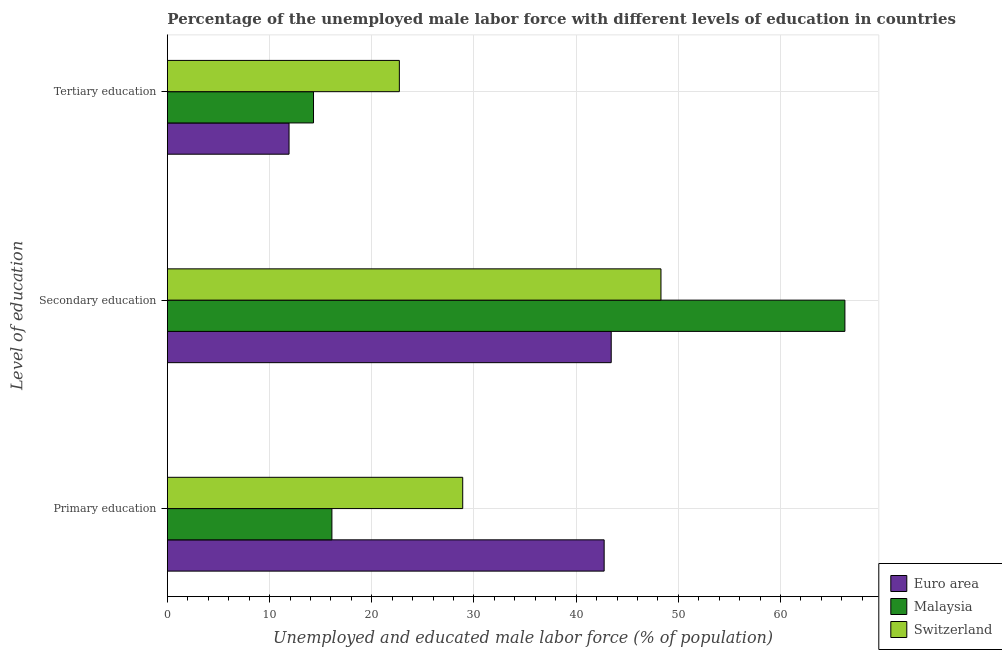Are the number of bars per tick equal to the number of legend labels?
Provide a succinct answer. Yes. Are the number of bars on each tick of the Y-axis equal?
Your response must be concise. Yes. How many bars are there on the 3rd tick from the top?
Ensure brevity in your answer.  3. What is the label of the 1st group of bars from the top?
Make the answer very short. Tertiary education. What is the percentage of male labor force who received secondary education in Euro area?
Your answer should be very brief. 43.43. Across all countries, what is the maximum percentage of male labor force who received primary education?
Offer a terse response. 42.74. Across all countries, what is the minimum percentage of male labor force who received tertiary education?
Make the answer very short. 11.9. In which country was the percentage of male labor force who received tertiary education maximum?
Ensure brevity in your answer.  Switzerland. What is the total percentage of male labor force who received secondary education in the graph?
Offer a very short reply. 158.03. What is the difference between the percentage of male labor force who received secondary education in Switzerland and that in Malaysia?
Provide a succinct answer. -18. What is the difference between the percentage of male labor force who received secondary education in Malaysia and the percentage of male labor force who received tertiary education in Euro area?
Give a very brief answer. 54.4. What is the average percentage of male labor force who received primary education per country?
Offer a terse response. 29.25. What is the difference between the percentage of male labor force who received secondary education and percentage of male labor force who received tertiary education in Switzerland?
Your response must be concise. 25.6. What is the ratio of the percentage of male labor force who received primary education in Malaysia to that in Switzerland?
Make the answer very short. 0.56. Is the percentage of male labor force who received tertiary education in Switzerland less than that in Malaysia?
Provide a short and direct response. No. Is the difference between the percentage of male labor force who received tertiary education in Malaysia and Switzerland greater than the difference between the percentage of male labor force who received primary education in Malaysia and Switzerland?
Offer a very short reply. Yes. What is the difference between the highest and the second highest percentage of male labor force who received tertiary education?
Give a very brief answer. 8.4. What is the difference between the highest and the lowest percentage of male labor force who received primary education?
Ensure brevity in your answer.  26.64. In how many countries, is the percentage of male labor force who received tertiary education greater than the average percentage of male labor force who received tertiary education taken over all countries?
Offer a terse response. 1. What does the 1st bar from the bottom in Tertiary education represents?
Your response must be concise. Euro area. How many countries are there in the graph?
Keep it short and to the point. 3. Does the graph contain any zero values?
Make the answer very short. No. Where does the legend appear in the graph?
Keep it short and to the point. Bottom right. What is the title of the graph?
Your answer should be compact. Percentage of the unemployed male labor force with different levels of education in countries. What is the label or title of the X-axis?
Ensure brevity in your answer.  Unemployed and educated male labor force (% of population). What is the label or title of the Y-axis?
Keep it short and to the point. Level of education. What is the Unemployed and educated male labor force (% of population) of Euro area in Primary education?
Your answer should be very brief. 42.74. What is the Unemployed and educated male labor force (% of population) in Malaysia in Primary education?
Your answer should be compact. 16.1. What is the Unemployed and educated male labor force (% of population) of Switzerland in Primary education?
Keep it short and to the point. 28.9. What is the Unemployed and educated male labor force (% of population) of Euro area in Secondary education?
Your answer should be compact. 43.43. What is the Unemployed and educated male labor force (% of population) in Malaysia in Secondary education?
Keep it short and to the point. 66.3. What is the Unemployed and educated male labor force (% of population) of Switzerland in Secondary education?
Offer a terse response. 48.3. What is the Unemployed and educated male labor force (% of population) in Euro area in Tertiary education?
Your response must be concise. 11.9. What is the Unemployed and educated male labor force (% of population) of Malaysia in Tertiary education?
Give a very brief answer. 14.3. What is the Unemployed and educated male labor force (% of population) in Switzerland in Tertiary education?
Make the answer very short. 22.7. Across all Level of education, what is the maximum Unemployed and educated male labor force (% of population) in Euro area?
Ensure brevity in your answer.  43.43. Across all Level of education, what is the maximum Unemployed and educated male labor force (% of population) of Malaysia?
Offer a terse response. 66.3. Across all Level of education, what is the maximum Unemployed and educated male labor force (% of population) in Switzerland?
Your answer should be compact. 48.3. Across all Level of education, what is the minimum Unemployed and educated male labor force (% of population) of Euro area?
Make the answer very short. 11.9. Across all Level of education, what is the minimum Unemployed and educated male labor force (% of population) of Malaysia?
Your response must be concise. 14.3. Across all Level of education, what is the minimum Unemployed and educated male labor force (% of population) of Switzerland?
Offer a very short reply. 22.7. What is the total Unemployed and educated male labor force (% of population) in Euro area in the graph?
Your answer should be very brief. 98.08. What is the total Unemployed and educated male labor force (% of population) of Malaysia in the graph?
Offer a terse response. 96.7. What is the total Unemployed and educated male labor force (% of population) of Switzerland in the graph?
Keep it short and to the point. 99.9. What is the difference between the Unemployed and educated male labor force (% of population) in Euro area in Primary education and that in Secondary education?
Give a very brief answer. -0.69. What is the difference between the Unemployed and educated male labor force (% of population) in Malaysia in Primary education and that in Secondary education?
Make the answer very short. -50.2. What is the difference between the Unemployed and educated male labor force (% of population) in Switzerland in Primary education and that in Secondary education?
Your answer should be very brief. -19.4. What is the difference between the Unemployed and educated male labor force (% of population) of Euro area in Primary education and that in Tertiary education?
Your answer should be compact. 30.84. What is the difference between the Unemployed and educated male labor force (% of population) in Malaysia in Primary education and that in Tertiary education?
Ensure brevity in your answer.  1.8. What is the difference between the Unemployed and educated male labor force (% of population) of Euro area in Secondary education and that in Tertiary education?
Ensure brevity in your answer.  31.53. What is the difference between the Unemployed and educated male labor force (% of population) of Malaysia in Secondary education and that in Tertiary education?
Your answer should be compact. 52. What is the difference between the Unemployed and educated male labor force (% of population) in Switzerland in Secondary education and that in Tertiary education?
Ensure brevity in your answer.  25.6. What is the difference between the Unemployed and educated male labor force (% of population) in Euro area in Primary education and the Unemployed and educated male labor force (% of population) in Malaysia in Secondary education?
Offer a very short reply. -23.56. What is the difference between the Unemployed and educated male labor force (% of population) of Euro area in Primary education and the Unemployed and educated male labor force (% of population) of Switzerland in Secondary education?
Provide a short and direct response. -5.56. What is the difference between the Unemployed and educated male labor force (% of population) in Malaysia in Primary education and the Unemployed and educated male labor force (% of population) in Switzerland in Secondary education?
Make the answer very short. -32.2. What is the difference between the Unemployed and educated male labor force (% of population) of Euro area in Primary education and the Unemployed and educated male labor force (% of population) of Malaysia in Tertiary education?
Make the answer very short. 28.44. What is the difference between the Unemployed and educated male labor force (% of population) of Euro area in Primary education and the Unemployed and educated male labor force (% of population) of Switzerland in Tertiary education?
Provide a short and direct response. 20.04. What is the difference between the Unemployed and educated male labor force (% of population) of Euro area in Secondary education and the Unemployed and educated male labor force (% of population) of Malaysia in Tertiary education?
Make the answer very short. 29.13. What is the difference between the Unemployed and educated male labor force (% of population) of Euro area in Secondary education and the Unemployed and educated male labor force (% of population) of Switzerland in Tertiary education?
Ensure brevity in your answer.  20.73. What is the difference between the Unemployed and educated male labor force (% of population) in Malaysia in Secondary education and the Unemployed and educated male labor force (% of population) in Switzerland in Tertiary education?
Ensure brevity in your answer.  43.6. What is the average Unemployed and educated male labor force (% of population) in Euro area per Level of education?
Keep it short and to the point. 32.69. What is the average Unemployed and educated male labor force (% of population) in Malaysia per Level of education?
Give a very brief answer. 32.23. What is the average Unemployed and educated male labor force (% of population) in Switzerland per Level of education?
Offer a terse response. 33.3. What is the difference between the Unemployed and educated male labor force (% of population) in Euro area and Unemployed and educated male labor force (% of population) in Malaysia in Primary education?
Make the answer very short. 26.64. What is the difference between the Unemployed and educated male labor force (% of population) of Euro area and Unemployed and educated male labor force (% of population) of Switzerland in Primary education?
Your answer should be compact. 13.84. What is the difference between the Unemployed and educated male labor force (% of population) in Malaysia and Unemployed and educated male labor force (% of population) in Switzerland in Primary education?
Your answer should be compact. -12.8. What is the difference between the Unemployed and educated male labor force (% of population) in Euro area and Unemployed and educated male labor force (% of population) in Malaysia in Secondary education?
Make the answer very short. -22.87. What is the difference between the Unemployed and educated male labor force (% of population) in Euro area and Unemployed and educated male labor force (% of population) in Switzerland in Secondary education?
Make the answer very short. -4.87. What is the difference between the Unemployed and educated male labor force (% of population) of Euro area and Unemployed and educated male labor force (% of population) of Malaysia in Tertiary education?
Offer a very short reply. -2.4. What is the difference between the Unemployed and educated male labor force (% of population) of Euro area and Unemployed and educated male labor force (% of population) of Switzerland in Tertiary education?
Provide a short and direct response. -10.79. What is the ratio of the Unemployed and educated male labor force (% of population) of Euro area in Primary education to that in Secondary education?
Offer a very short reply. 0.98. What is the ratio of the Unemployed and educated male labor force (% of population) of Malaysia in Primary education to that in Secondary education?
Your response must be concise. 0.24. What is the ratio of the Unemployed and educated male labor force (% of population) of Switzerland in Primary education to that in Secondary education?
Your answer should be compact. 0.6. What is the ratio of the Unemployed and educated male labor force (% of population) in Euro area in Primary education to that in Tertiary education?
Your answer should be compact. 3.59. What is the ratio of the Unemployed and educated male labor force (% of population) in Malaysia in Primary education to that in Tertiary education?
Your response must be concise. 1.13. What is the ratio of the Unemployed and educated male labor force (% of population) in Switzerland in Primary education to that in Tertiary education?
Your response must be concise. 1.27. What is the ratio of the Unemployed and educated male labor force (% of population) of Euro area in Secondary education to that in Tertiary education?
Provide a succinct answer. 3.65. What is the ratio of the Unemployed and educated male labor force (% of population) in Malaysia in Secondary education to that in Tertiary education?
Your response must be concise. 4.64. What is the ratio of the Unemployed and educated male labor force (% of population) in Switzerland in Secondary education to that in Tertiary education?
Your answer should be very brief. 2.13. What is the difference between the highest and the second highest Unemployed and educated male labor force (% of population) in Euro area?
Your response must be concise. 0.69. What is the difference between the highest and the second highest Unemployed and educated male labor force (% of population) of Malaysia?
Your answer should be compact. 50.2. What is the difference between the highest and the lowest Unemployed and educated male labor force (% of population) of Euro area?
Offer a terse response. 31.53. What is the difference between the highest and the lowest Unemployed and educated male labor force (% of population) of Switzerland?
Offer a terse response. 25.6. 